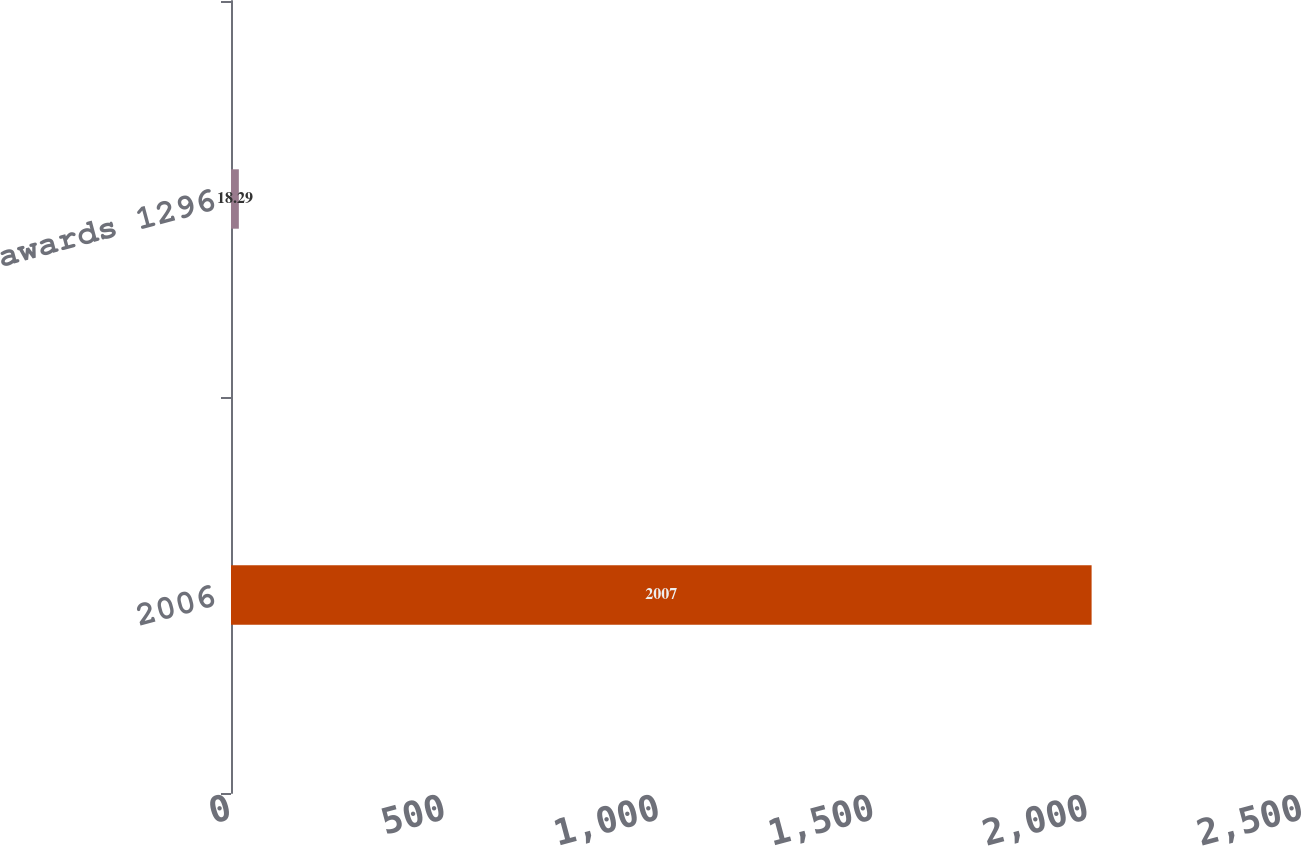Convert chart to OTSL. <chart><loc_0><loc_0><loc_500><loc_500><bar_chart><fcel>2006<fcel>Stock awards 1296<nl><fcel>2007<fcel>18.29<nl></chart> 